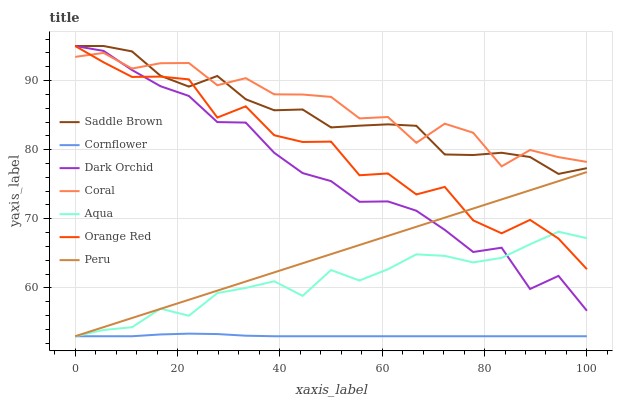Does Cornflower have the minimum area under the curve?
Answer yes or no. Yes. Does Coral have the maximum area under the curve?
Answer yes or no. Yes. Does Aqua have the minimum area under the curve?
Answer yes or no. No. Does Aqua have the maximum area under the curve?
Answer yes or no. No. Is Peru the smoothest?
Answer yes or no. Yes. Is Orange Red the roughest?
Answer yes or no. Yes. Is Coral the smoothest?
Answer yes or no. No. Is Coral the roughest?
Answer yes or no. No. Does Cornflower have the lowest value?
Answer yes or no. Yes. Does Coral have the lowest value?
Answer yes or no. No. Does Saddle Brown have the highest value?
Answer yes or no. Yes. Does Coral have the highest value?
Answer yes or no. No. Is Cornflower less than Coral?
Answer yes or no. Yes. Is Coral greater than Peru?
Answer yes or no. Yes. Does Aqua intersect Dark Orchid?
Answer yes or no. Yes. Is Aqua less than Dark Orchid?
Answer yes or no. No. Is Aqua greater than Dark Orchid?
Answer yes or no. No. Does Cornflower intersect Coral?
Answer yes or no. No. 